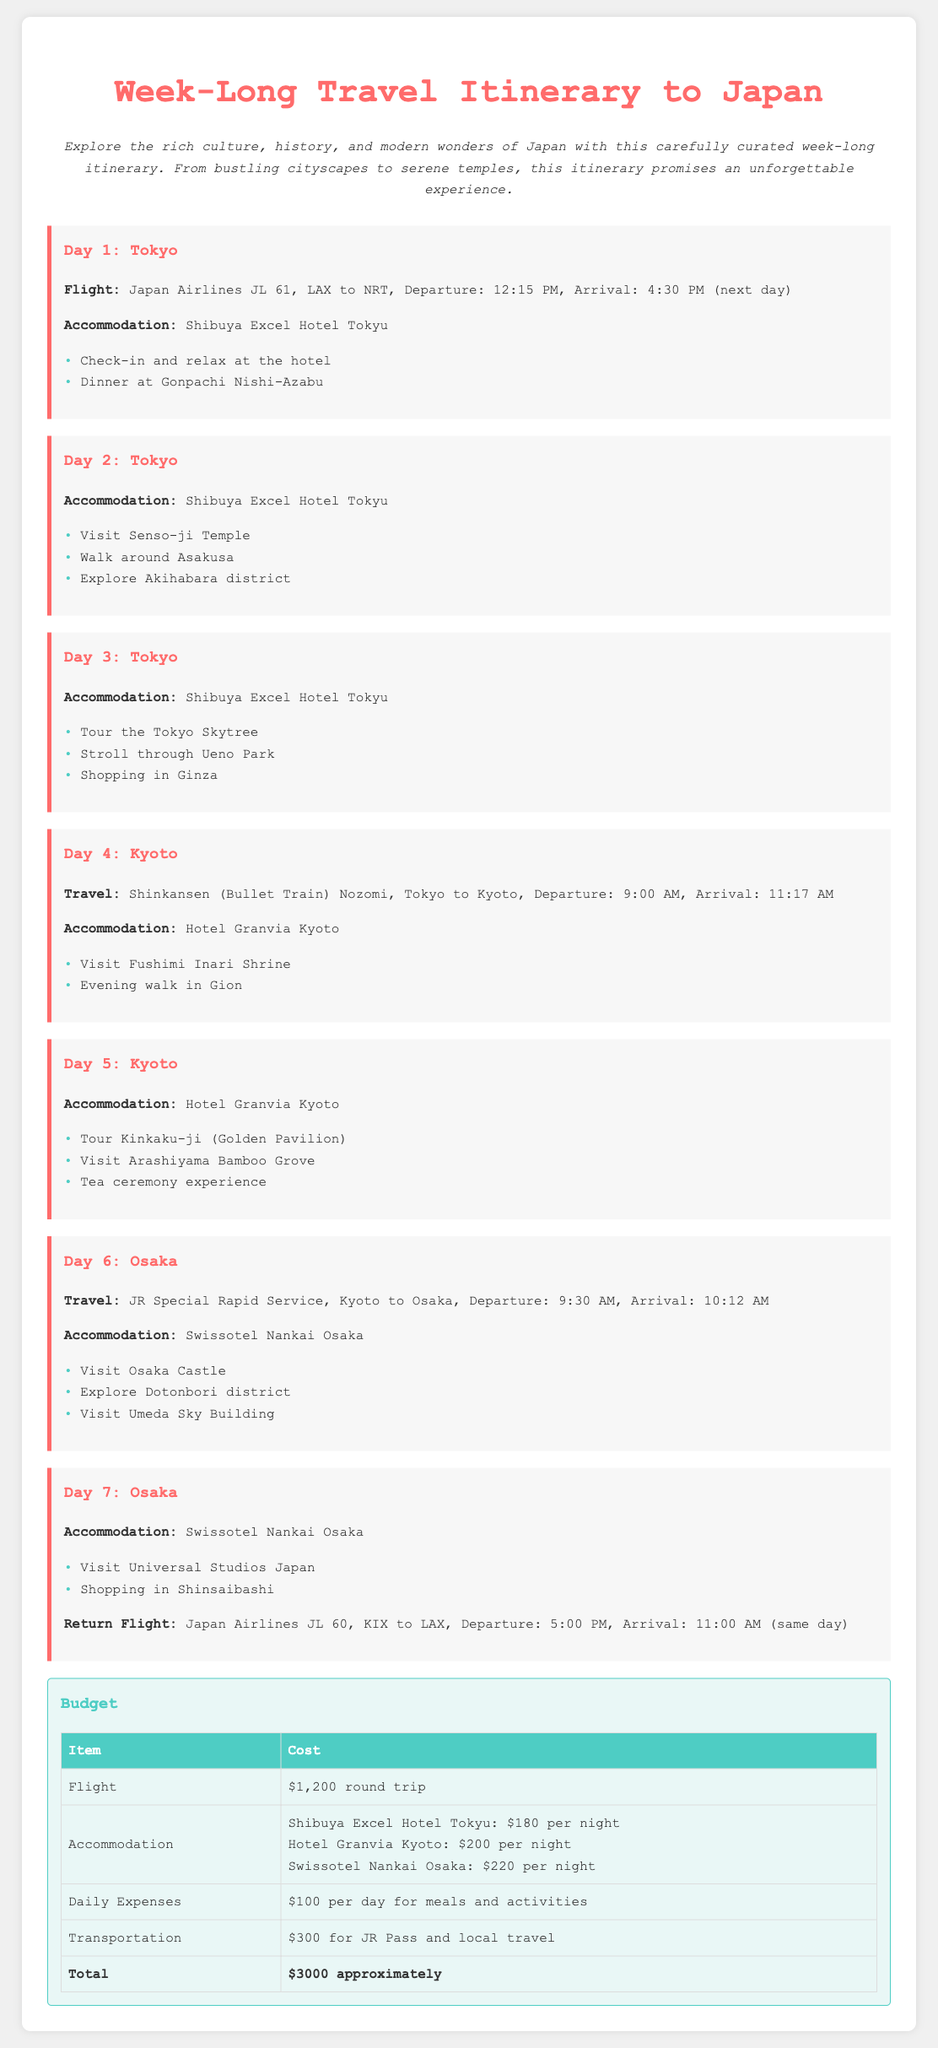What is the total budget for the trip? The total budget is listed at the end of the document as approximately $3000.
Answer: $3000 What flight does the trip start with? The flight for the trip is Japan Airlines JL 61, from LAX to NRT.
Answer: Japan Airlines JL 61 What is the accommodation on Day 1? The accommodation for Day 1 is Shibuya Excel Hotel Tokyu.
Answer: Shibuya Excel Hotel Tokyu How many days are spent in Osaka? The itinerary shows that there are two days spent in Osaka.
Answer: 2 days What time does the return flight depart? The return flight departs at 5:00 PM according to the itinerary.
Answer: 5:00 PM Which train service is used to travel from Kyoto to Osaka? The train service used is the JR Special Rapid Service.
Answer: JR Special Rapid Service What is the accommodation cost per night in Kyoto? The accommodation cost per night in Kyoto at Hotel Granvia is $200.
Answer: $200 What is one activity planned for Day 6? One activity planned for Day 6 is to visit Osaka Castle.
Answer: Visit Osaka Castle What time does the Shinkansen departure happen on Day 4? The Shinkansen departs at 9:00 AM on Day 4.
Answer: 9:00 AM 